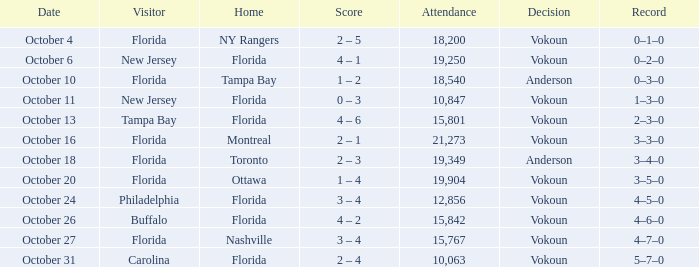What was the score on October 31? 2 – 4. 